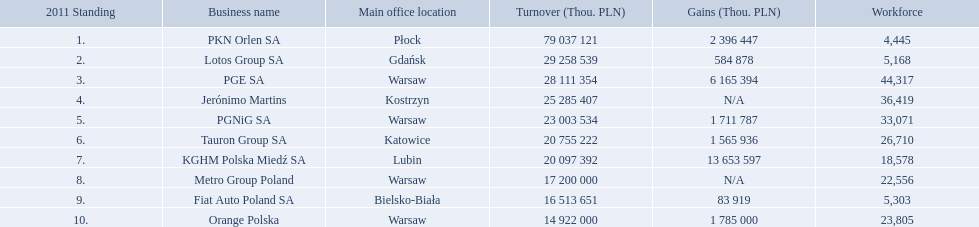What company has 28 111 354 thou.in revenue? PGE SA. What revenue does lotus group sa have? 29 258 539. Who has the next highest revenue than lotus group sa? PKN Orlen SA. Which concern's headquarters are located in warsaw? PGE SA, PGNiG SA, Metro Group Poland. Which of these listed a profit? PGE SA, PGNiG SA. Of these how many employees are in the concern with the lowest profit? 33,071. 